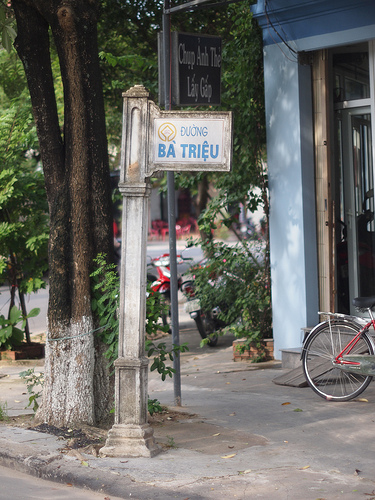Imagine the signpost could talk. What would it say about its history? The signpost, aged yet sturdy, might say, 'I have seen this street change and grow. From the bustling market scenes of decades past to the modern rhythms of today, I stand as a witness to countless stories of joy, sorrow, and everyday life. I have guided travelers, marked significant events, and been a silent companion to those who needed direction. My paint may chip and weather, but my purpose remains steadfast, illuminating this street's legacy and future.' Describe a bustling day on this street with as much detail as possible. On a bustling day, the street is alive with activity. Motorbikes weave through the lanes, honking sporadically while vendors call out their best deals. The aroma of street food fills the air, mingling with the scent of fresh flowers from a nearby stall. The sign 'DUONG BA TRIEU' stands tall, guiding locals and tourists alike. People of all ages crowd the sidewalk, some hastily making their way to work while others casually window-shop. Children play near the street, their laughter mixing with the hum of conversations in various languages. A group of elderly friends sit by the corner café, sipping coffee and reminiscing about the old days. The trees provide much-needed shade, casting dancing shadows on the pavement. Amidst the chaos, there's a harmonious rhythm, a heartbeat that defines this street, making it a unique blend of tradition and modernity. If you could change one thing about this image, what would it be and why? If I could change one thing about this image, I would introduce more street-level activity to enhance the dynamism of the scene. Adding people walking, a couple of street vendors, and perhaps a parked motorbike would breathe life into the picture, making the street feel more lived-in and bustling. 